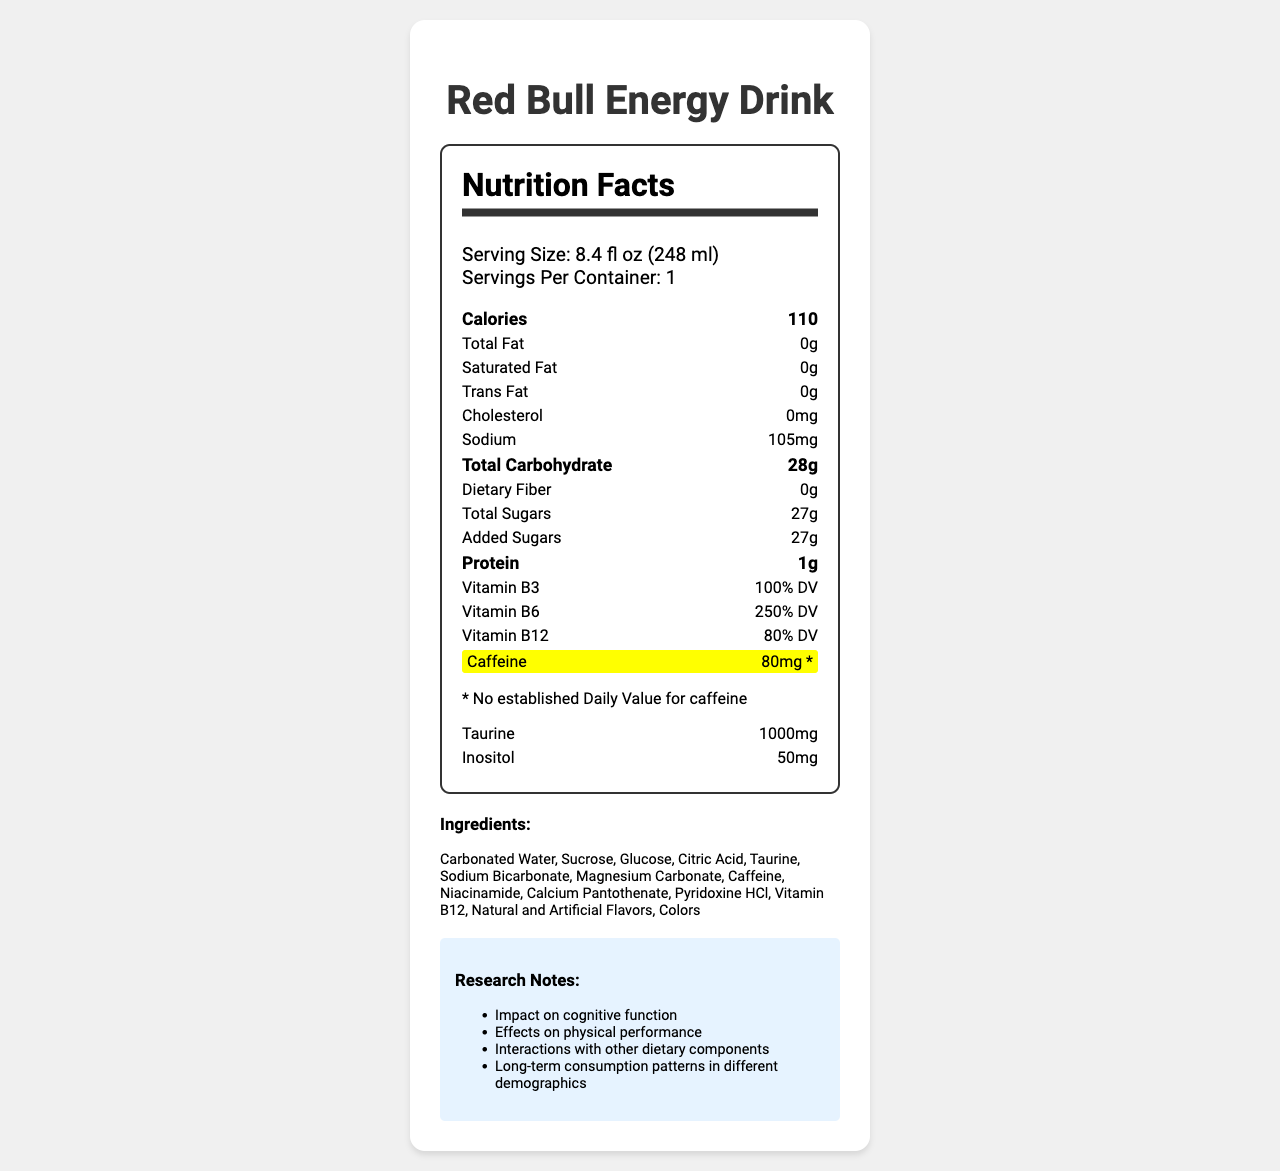what is the serving size for Red Bull Energy Drink? The serving size is listed as "8.4 fl oz (248 ml)" in the serving information section.
Answer: 8.4 fl oz (248 ml) How much sodium is in one serving of Red Bull Energy Drink? The document lists sodium content as 105mg.
Answer: 105mg What is the total carbohydrate content in one serving? The total carbohydrate content is specified as 28g in the nutrition facts section.
Answer: 28g Name three major ingredients in Red Bull Energy Drink. The ingredients list starts with Carbonated Water, Sucrose, and Glucose.
Answer: Carbonated Water, Sucrose, Glucose How much caffeine does one can of Red Bull Energy Drink contain? The caffeine content highlighted in the document is 80mg.
Answer: 80mg What percentage of the daily value of Vitamin B6 does one serving of Red Bull provide? The label indicates that Vitamin B6 has a daily value percentage of 250%.
Answer: 250% DV Is there any dietary fiber in Red Bull Energy Drink? The dietary fiber content is listed as 0g, meaning there is no dietary fiber.
Answer: No Which vitamin has the highest daily value percentage in Red Bull Energy Drink? A. Vitamin B3 B. Vitamin B6 C. Vitamin B12 The daily value percentages are Vitamin B3 - 100%, Vitamin B6 - 250%, and Vitamin B12 - 80%. Therefore, Vitamin B6 has the highest percentage.
Answer: B What amount of Inositol is present in this energy drink? The document shows that Inositol is present in the amount of 50mg.
Answer: 50mg Does Red Bull Energy Drink contain any major allergens? The allergen information states that the product does not contain any major allergens.
Answer: No Which nutrient contributes the most to the total calories in one serving? A. Protein B. Total Sugars C. Total Fat Since total fat is 0g, protein is 1g, and total sugars are 27g, total sugars contribute the most to the total calories (54% of total calories comes from added sugars).
Answer: B Is there any added sugar in Red Bull Energy Drink? The document shows 27g of added sugars.
Answer: Yes Describe the main idea of the Nutrition Facts Label for Red Bull Energy Drink. The main idea centers on transparency about the beverage's nutritional content, especially its high sugar and caffeine content, along with its vitamin supplementation and other ingredients.
Answer: The Nutrition Facts Label provides detailed information about the nutritional content, ingredients, and serving information for Red Bull Energy Drink. It highlights the caffeine content (80mg) and includes data on calories, fats, carbohydrates, sugars, proteins, and vitamins, as well as some research notes and suggested study areas. What is the color of the highlighted section on caffeine? The caffeine amount is highlighted with a yellow background in the document.
Answer: Yellow Can the effects of taurine in energy drinks be determined from this document alone? The document mentions that the taurine content requires further investigation, indicating that its effects cannot be determined from this information alone.
Answer: No 